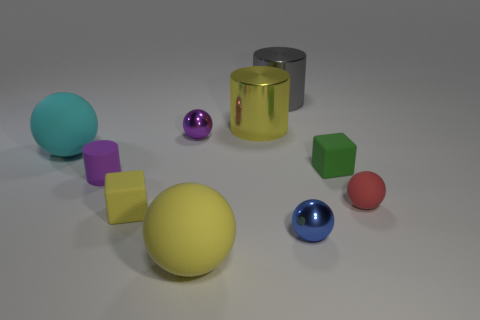Subtract all yellow balls. How many balls are left? 4 Subtract all yellow rubber spheres. How many spheres are left? 4 Subtract all gray spheres. Subtract all yellow cubes. How many spheres are left? 5 Subtract all cylinders. How many objects are left? 7 Subtract all tiny green objects. Subtract all small green matte cubes. How many objects are left? 8 Add 2 cyan rubber things. How many cyan rubber things are left? 3 Add 10 tiny red metallic cylinders. How many tiny red metallic cylinders exist? 10 Subtract 1 purple cylinders. How many objects are left? 9 